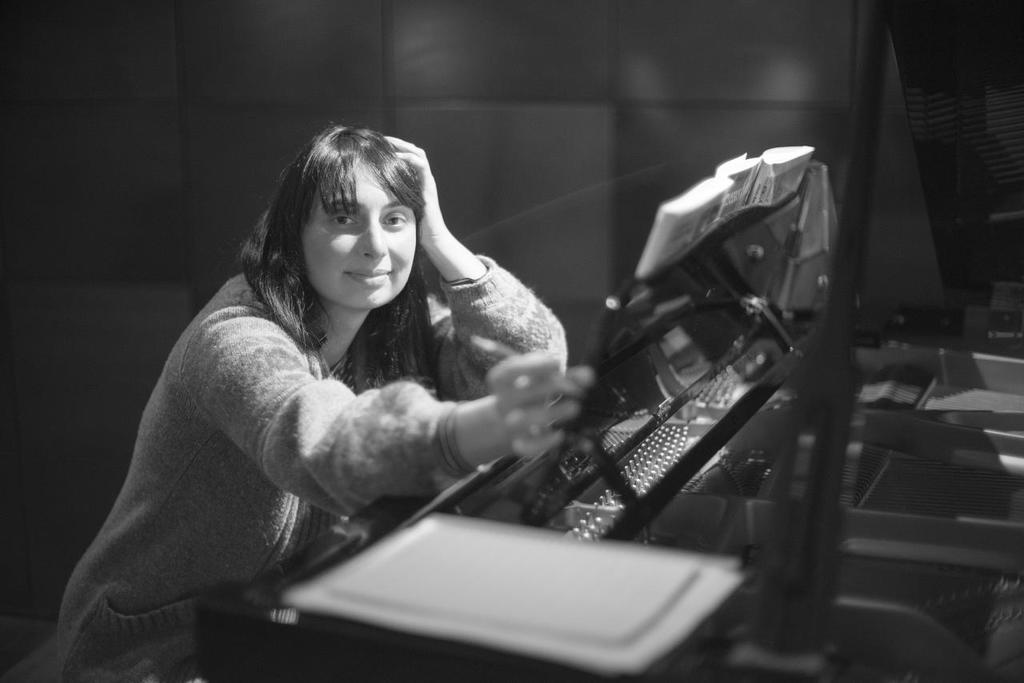What is the color scheme of the image? The image is black and white. Who is present in the image? There is a woman in the image. What is the woman doing in the image? The woman is sitting and smiling. What items are in front of the woman? There are papers and books in front of the woman. What object might the papers and books be resting on? There is an object in front of the woman, possibly a table or desk. What can be seen in the background of the image? There is a wall visible in the background of the image. Can you see the moon in the image? No, the moon is not visible in the image. Is the woman stretching in the image? The woman is sitting and smiling, but there is no indication that she is stretching. 